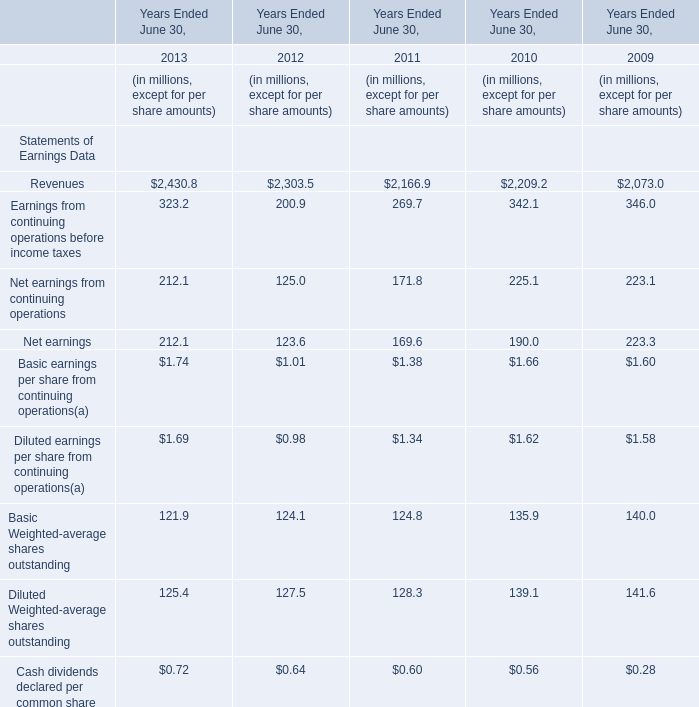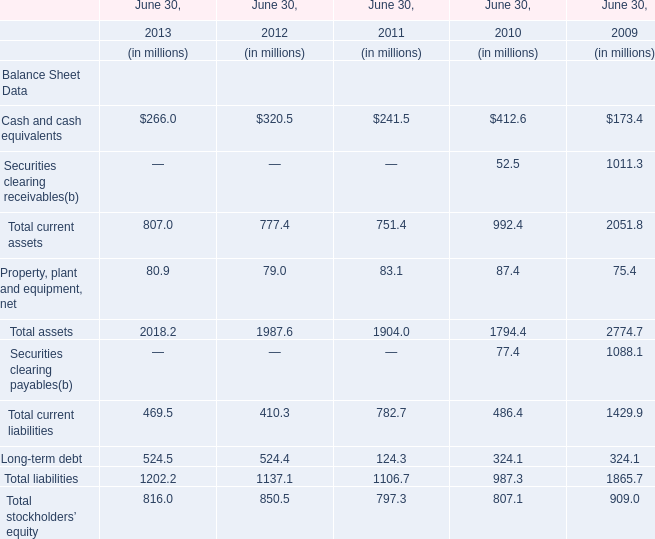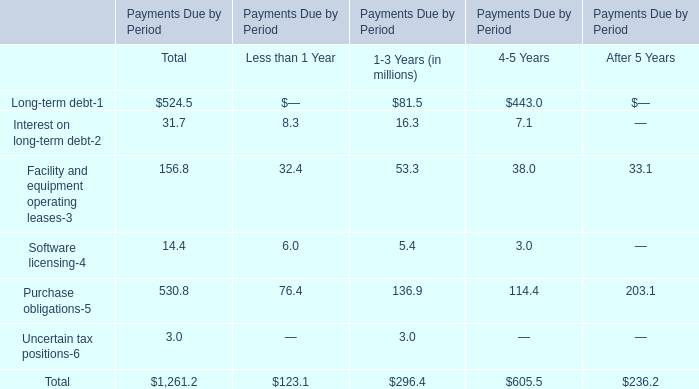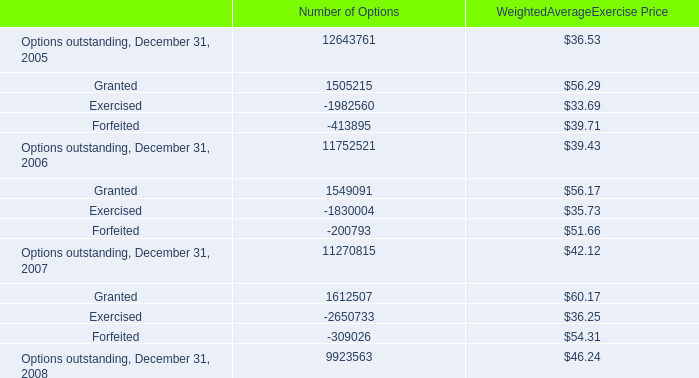Which year is Cash and cash equivalents the highest? 
Answer: 2010. 